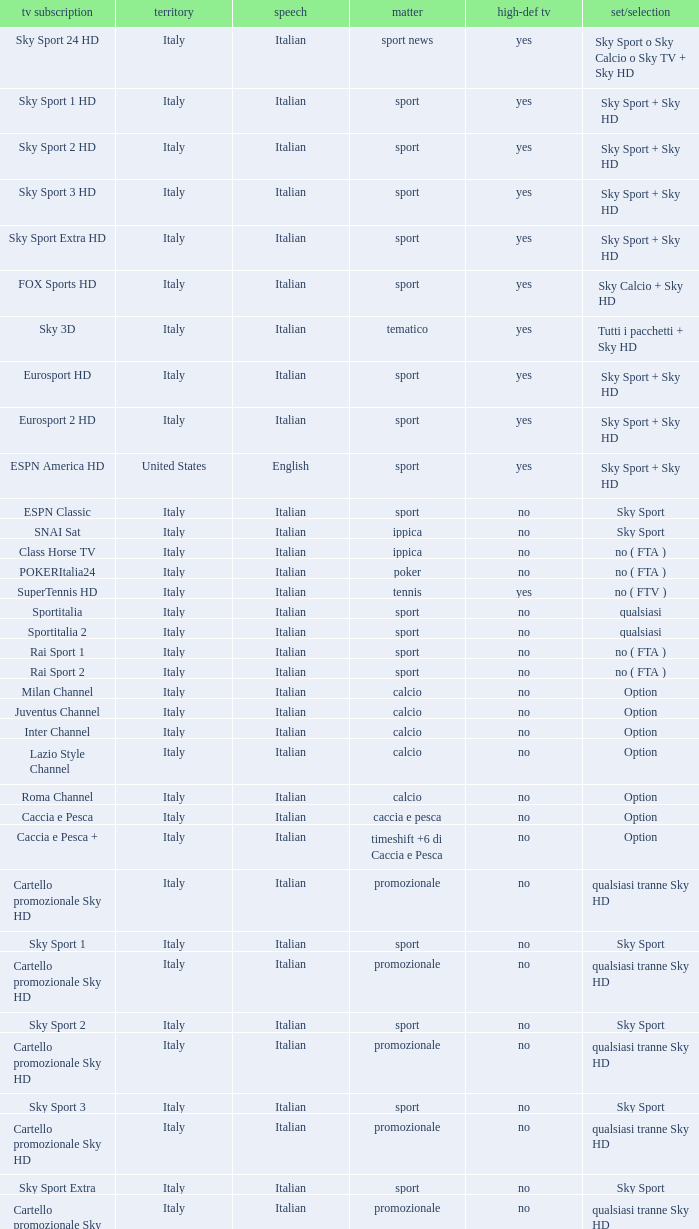What is Package/Option, when Content is Tennis? No ( ftv ). 